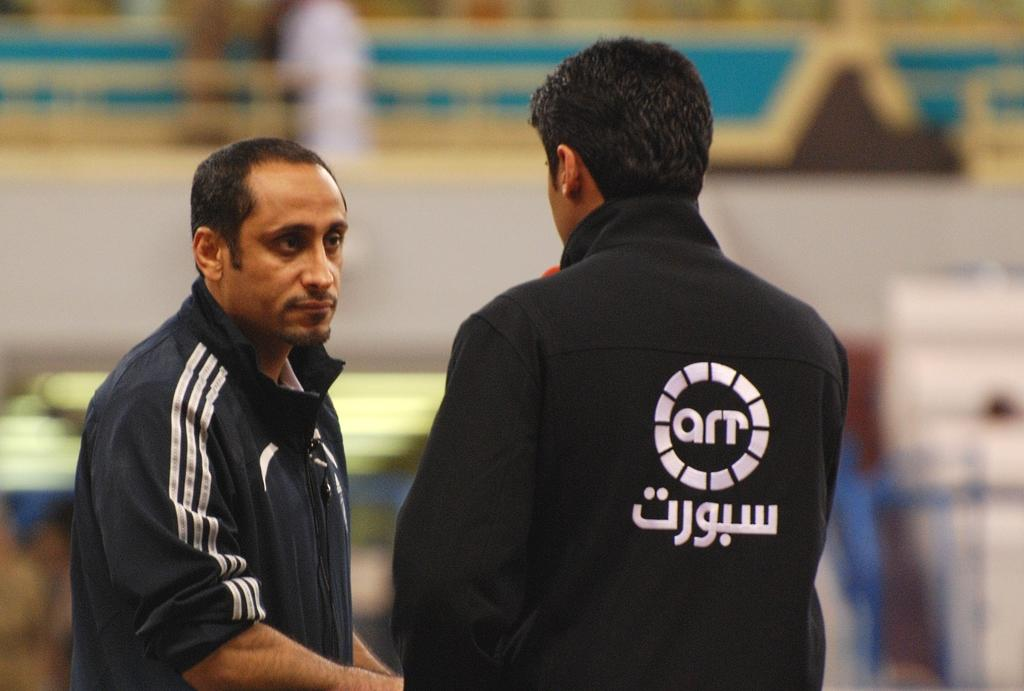Provide a one-sentence caption for the provided image. The two people here are working for a company called art. 